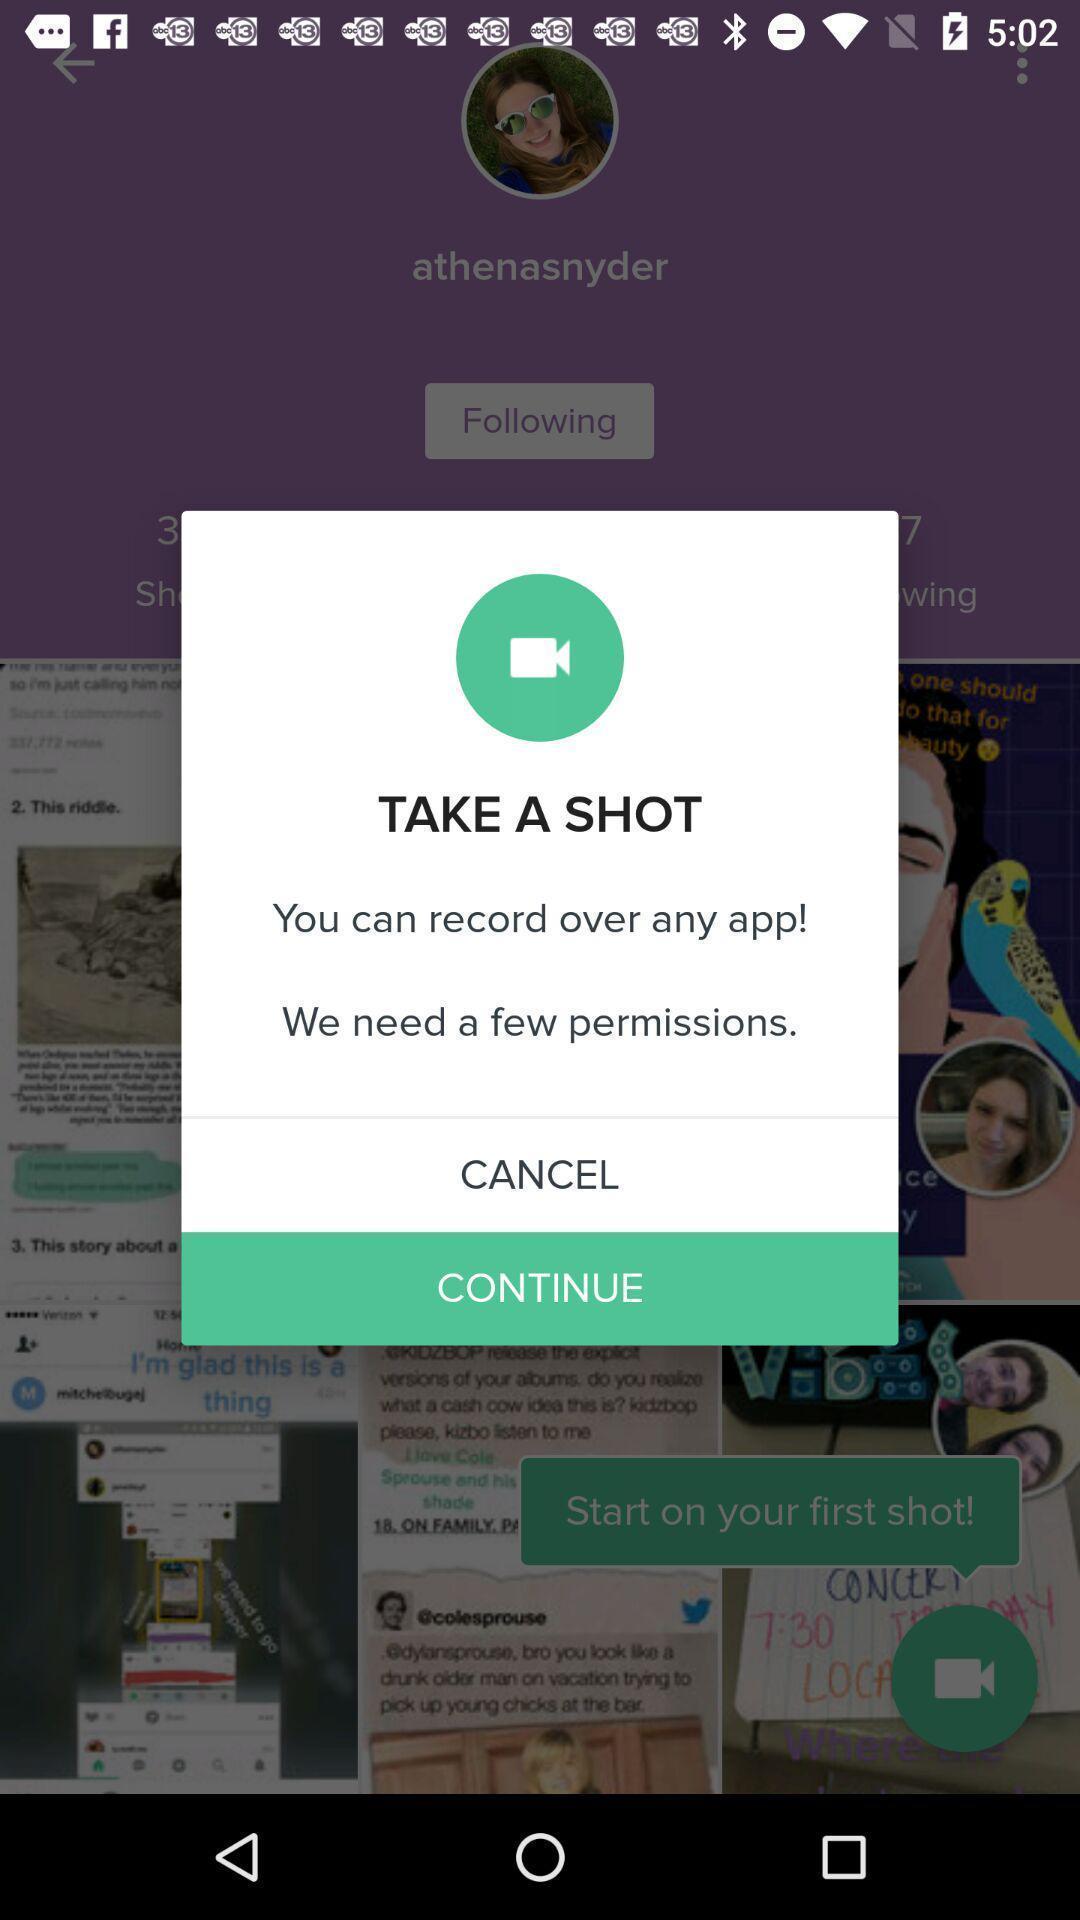Provide a detailed account of this screenshot. Pop-up shows take a shot to continue with app. 